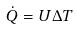Convert formula to latex. <formula><loc_0><loc_0><loc_500><loc_500>\dot { Q } = U \Delta T</formula> 